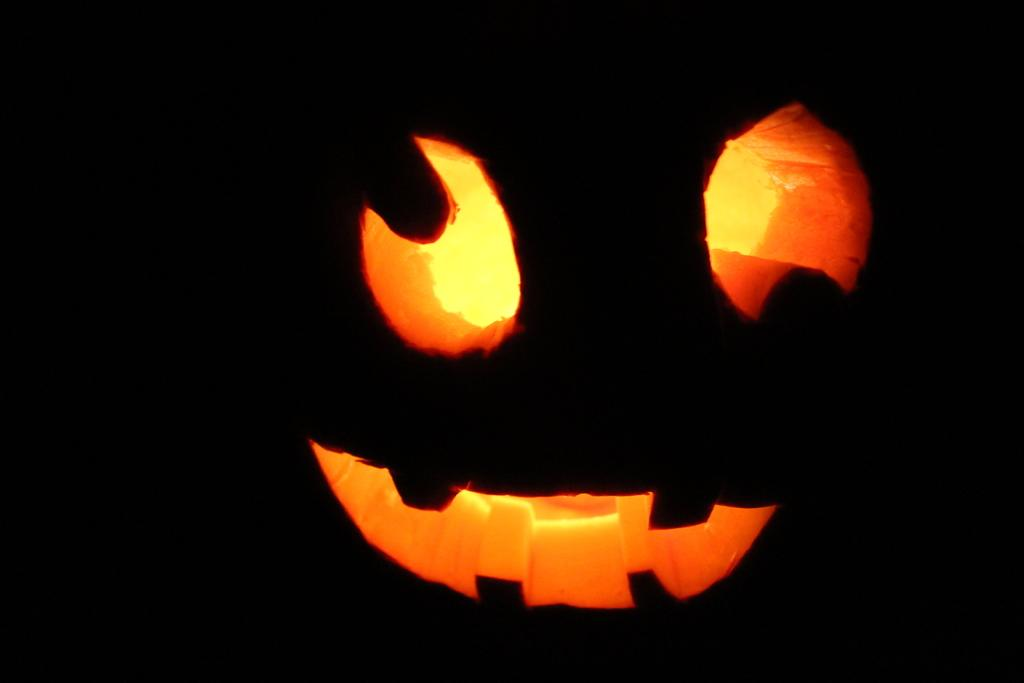What is the main subject of the image? There is a Halloween pumpkin in the center of the image. Can you describe the appearance of the pumpkin? The pumpkin is likely carved with a spooky or festive design, as it is a Halloween pumpkin. What is the context or theme of the image? The image is related to Halloween, as indicated by the presence of the Halloween pumpkin. How does the pumpkin turn into a car during the night in the image? The image does not depict the pumpkin turning into a car; it is a Halloween pumpkin that remains a pumpkin throughout the image. 